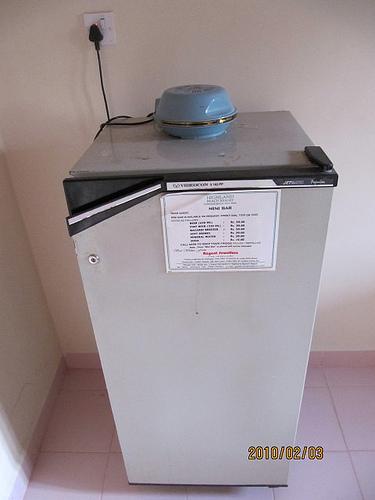Is the unit plugged in?
Write a very short answer. Yes. What color is the wall?
Be succinct. White. What is on top of the fridge?
Answer briefly. Bowl. 